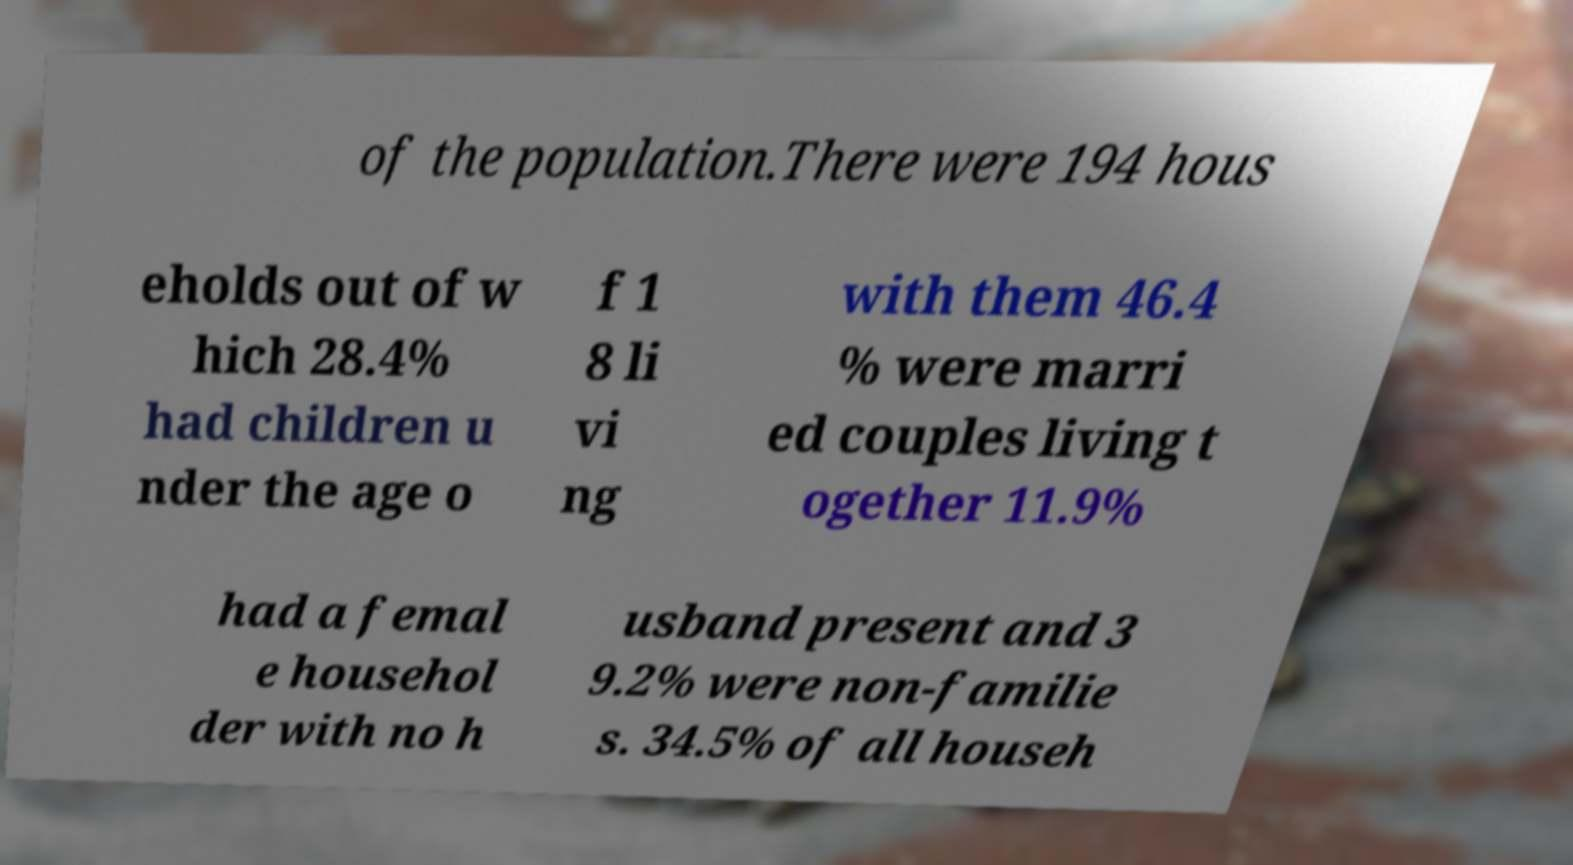What messages or text are displayed in this image? I need them in a readable, typed format. of the population.There were 194 hous eholds out of w hich 28.4% had children u nder the age o f 1 8 li vi ng with them 46.4 % were marri ed couples living t ogether 11.9% had a femal e househol der with no h usband present and 3 9.2% were non-familie s. 34.5% of all househ 